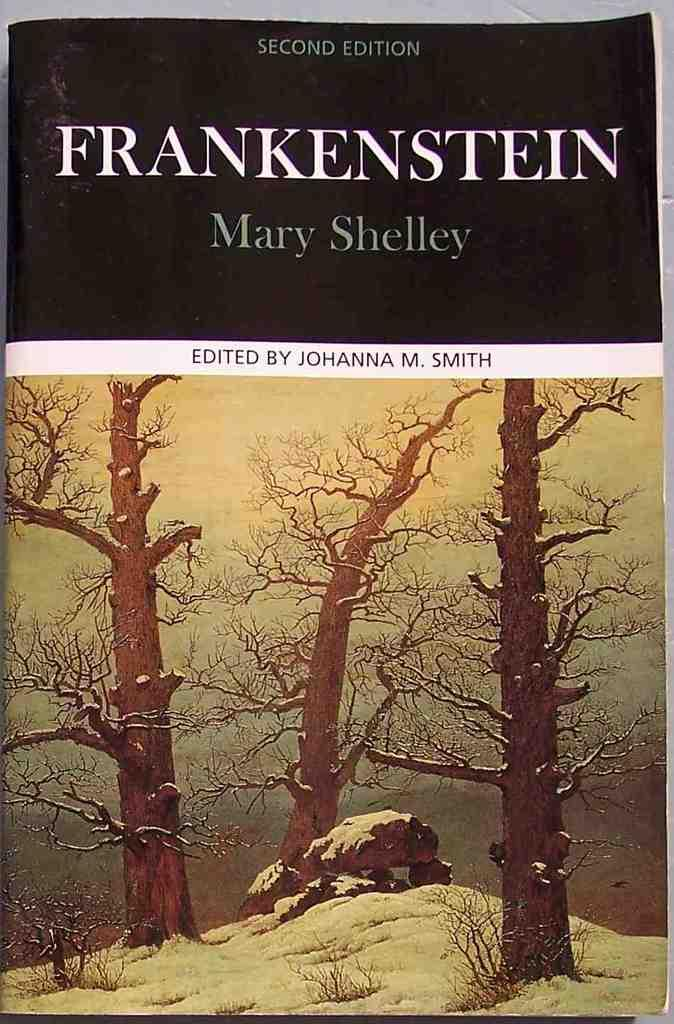<image>
Provide a brief description of the given image. A book called Frankenstein by Mary Shelley with a snowy forest on the cover. 